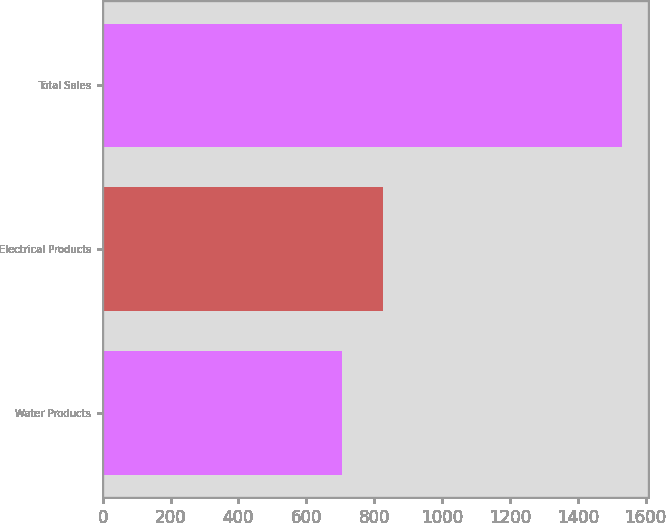Convert chart to OTSL. <chart><loc_0><loc_0><loc_500><loc_500><bar_chart><fcel>Water Products<fcel>Electrical Products<fcel>Total Sales<nl><fcel>706.1<fcel>824.6<fcel>1530.7<nl></chart> 